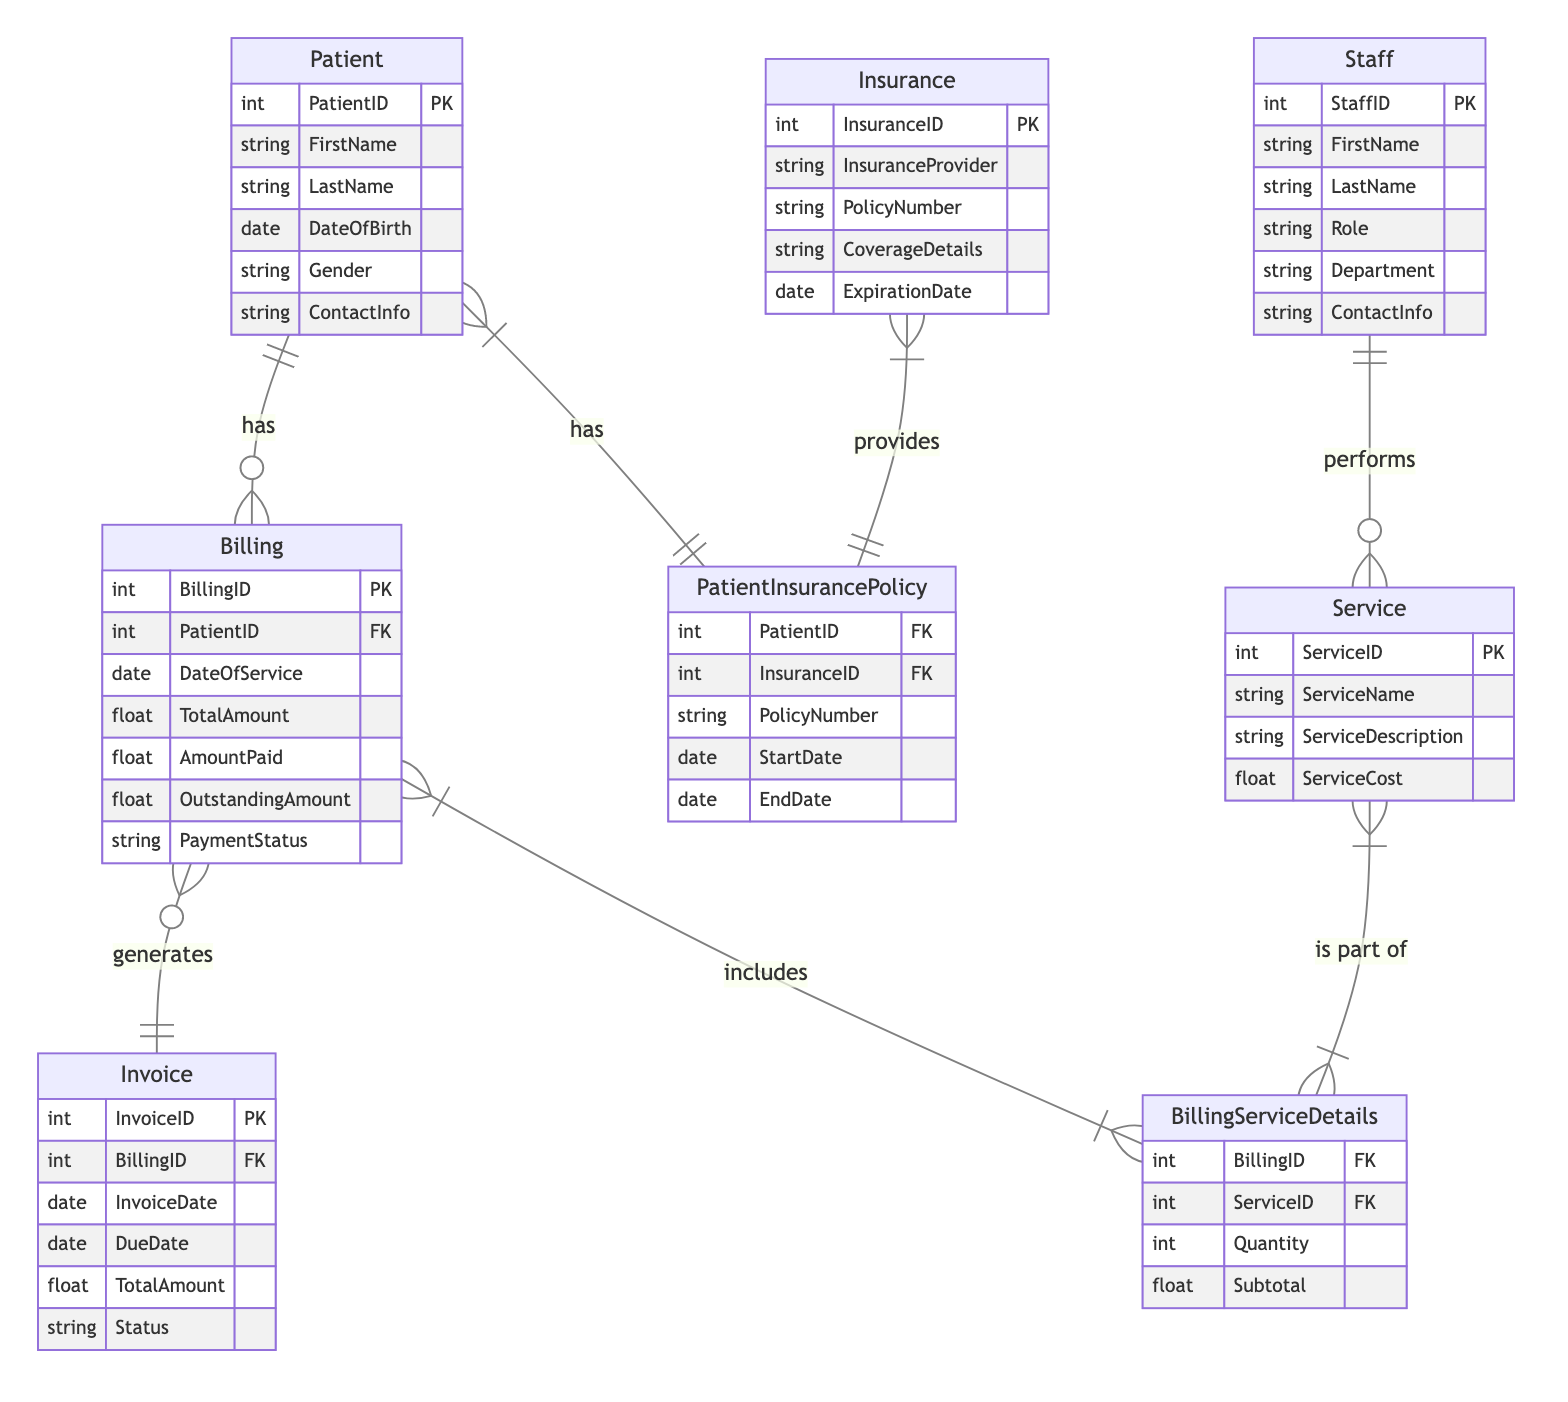What entity has the primary key PatientID? The diagram identifies "Patient" as an entity with the attribute PatientID, which is marked as the primary key (PK).
Answer: Patient How many attributes does the Billing entity have? The Billing entity is listed with a total of seven attributes: BillingID, PatientID, DateOfService, TotalAmount, AmountPaid, OutstandingAmount, and PaymentStatus.
Answer: Seven What type of relationship exists between Patient and Billing? The diagram indicates that the relationship between Patient and Billing is one-to-many, meaning a single patient can have multiple billing records.
Answer: One-to-many Which entity links Patient and Insurance? The diagram shows that the linking entity between Patient and Insurance is called "PatientInsurancePolicy." This entity serves as a bridge for their many-to-many relationship.
Answer: PatientInsurancePolicy How many services can each staff member perform? The diagram illustrates that the relationship between Staff and Service is one-to-many, meaning each staff member can perform multiple services.
Answer: Many What is the attribute name for the total amount on the Invoice? The Invoice entity contains an attribute named "TotalAmount," which represents the total monetary amount on the invoice.
Answer: TotalAmount How does Billing relate to Invoice in this diagram? The relationship between Billing and Invoice is a one-to-one relationship, indicating that each billing record corresponds to a single invoice.
Answer: One-to-one Which attributes identify the BillingServiceDetails entity? The BillingServiceDetails entity is identified by the attributes BillingID (from Billing) and ServiceID (from Service), which together create the linkage for the many-to-many relationship.
Answer: BillingID, ServiceID What is the role of the Staff entity in relation to Service? The Staff entity has a one-to-many relationship with Service, indicating that one staff member can perform multiple services.
Answer: Performs How is the outstanding amount in the Billing determined? The outstanding amount can be calculated as the total amount minus the amount paid, as indicated by the attributes of the Billing entity.
Answer: TotalAmount - AmountPaid 